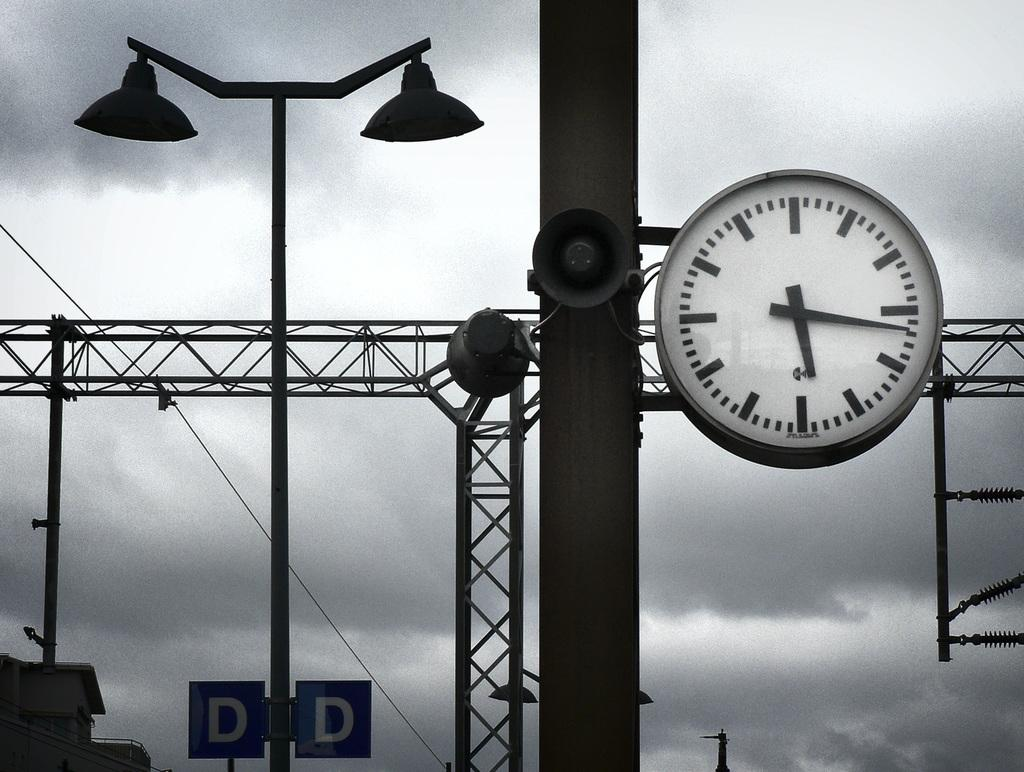<image>
Present a compact description of the photo's key features. The clock on platform D shows a time of 5:17. 